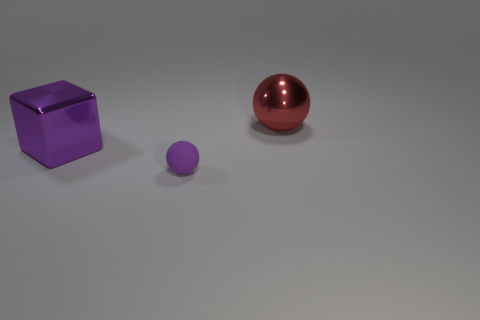Are there any shadows or lighting cues in the image that provide information about the objects' positions? Yes, there are shadows visible beneath the objects, which suggest a light source positioned above them, slightly to the right. The shadows are sharp and well-defined, indicating the light source may be strong and possibly direct. The positions of the shadows allow us to infer the spatial arrangement and relative heights of the objects.  Based on their shadows, which object appears to be the tallest? Based on the shadows and perspective, the cube appears to be the tallest object. Its shadow is elongated and offsets from the object significantly, suggesting it has the greatest height among the three. 